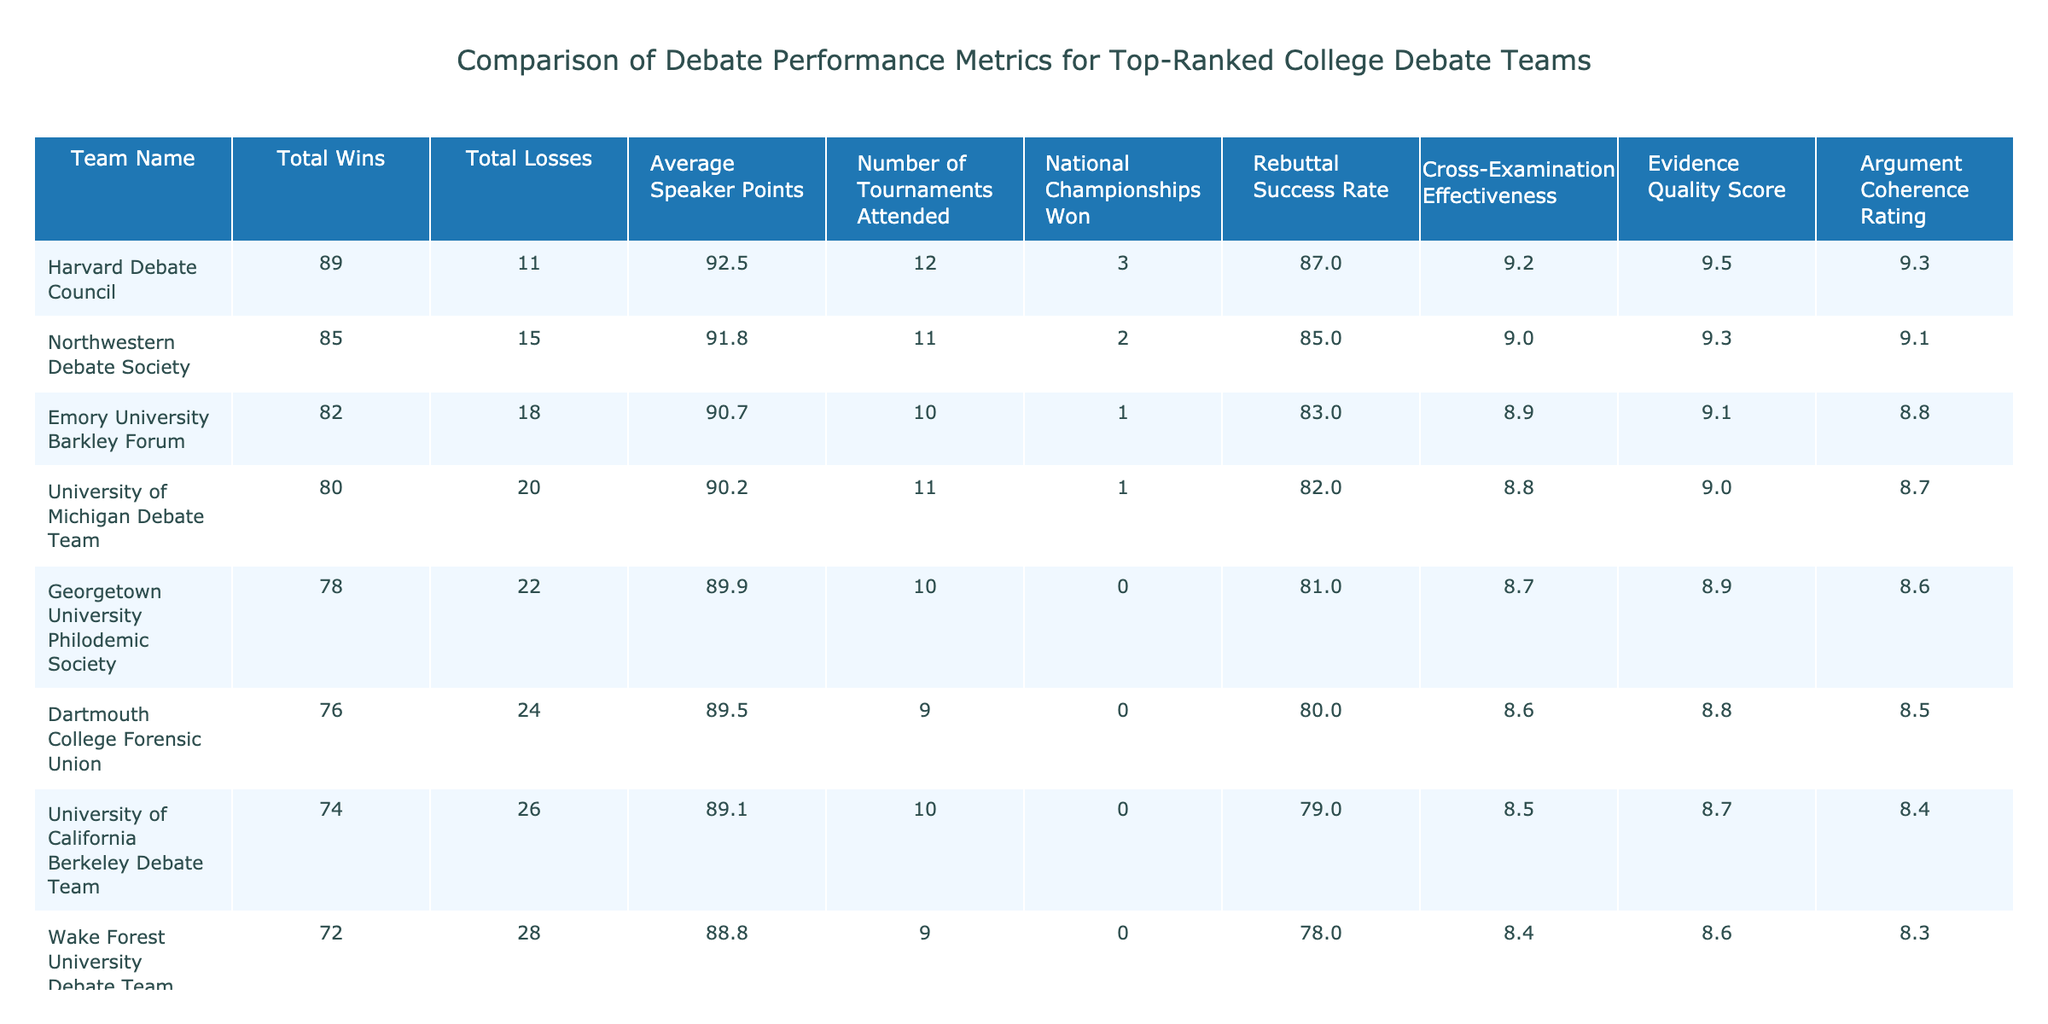What is the total number of wins for the Harvard Debate Council? The table indicates the total wins for each team, and the value for Harvard Debate Council is provided directly in the "Total Wins" column.
Answer: 89 What is the average speaker points of the University of Kansas Debate Team? Looking at the "Average Speaker Points" column, the value for the University of Kansas Debate Team is listed.
Answer: 88.4 Which team has the highest rebuttal success rate? By comparing the "Rebuttal Success Rate" values across all teams, Harvard Debate Council has the highest at 87%.
Answer: Harvard Debate Council What is the average number of tournaments attended by the teams listed in the table? To find the average, sum the "Number of Tournaments Attended" (12 + 11 + 10 + 11 + 10 + 9 + 10 + 9 + 8 + 8 = 88) and divide by the number of teams (10). So, 88/10 = 8.8.
Answer: 8.8 Is it true that the Emory University Barkley Forum has more total wins than the University of California Berkeley Debate Team? By comparing the "Total Wins" for both teams, Emory University has 82 wins while the University of California Berkeley has 74 wins, confirming the statement is true.
Answer: Yes What is the difference in average speaker points between the team with the most and the team with the least? The highest average speaker points is for Harvard Debate Council at 92.5, and the lowest is for Stanford Debate Society at 88.1. The difference is calculated as 92.5 - 88.1 = 4.4.
Answer: 4.4 Which team had the highest national championships won, and what is that number? In the "National Championships Won" column, Harvard Debate Council has won 3 national championships, which is the highest among all teams.
Answer: Harvard Debate Council, 3 If you consider the two teams with the most total losses, how many total losses do they have combined? The teams with the most losses are Stanford Debate Society with 32 and University of Kansas Debate Team with 30. The total losses combined is 32 + 30 = 62.
Answer: 62 Which team has the lowest evidence quality score? By inspecting the "Evidence Quality Score" column, we see that Stanford Debate Society has the lowest score of 8.1.
Answer: Stanford Debate Society What is the average rebuttal success rate for the top five teams? The rebuttal success rates for the top five teams are 87%, 85%, 83%, 82%, and 81%. Summing these values gives 418, and dividing by 5 gives an average of 83.6%.
Answer: 83.6% 